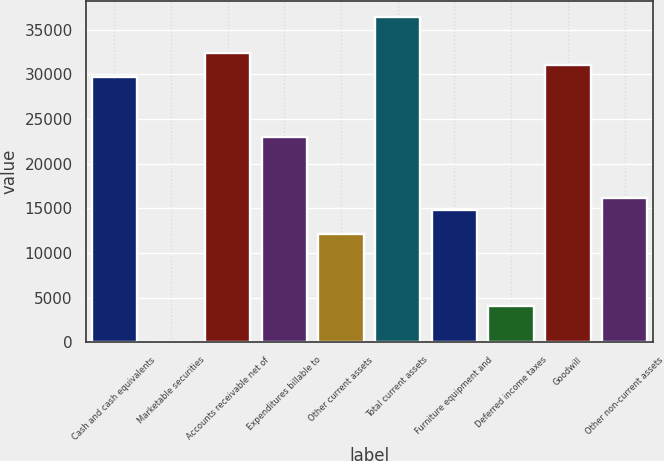Convert chart to OTSL. <chart><loc_0><loc_0><loc_500><loc_500><bar_chart><fcel>Cash and cash equivalents<fcel>Marketable securities<fcel>Accounts receivable net of<fcel>Expenditures billable to<fcel>Other current assets<fcel>Total current assets<fcel>Furniture equipment and<fcel>Deferred income taxes<fcel>Goodwill<fcel>Other non-current assets<nl><fcel>29667.4<fcel>16<fcel>32363<fcel>22928.4<fcel>12146.1<fcel>36406.3<fcel>14841.7<fcel>4059.37<fcel>31015.2<fcel>16189.5<nl></chart> 